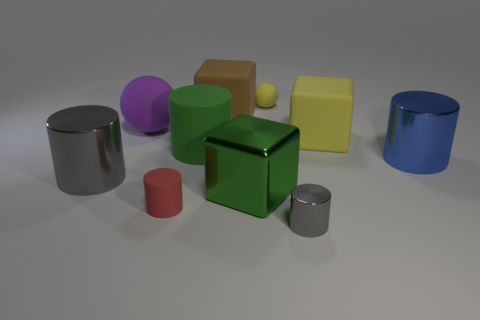What material is the big block that is the same color as the big matte cylinder?
Provide a succinct answer. Metal. What number of things are either large metal cylinders or tiny objects in front of the large blue object?
Provide a succinct answer. 4. Are there fewer green cylinders in front of the large green cube than large gray metal cylinders behind the large yellow rubber thing?
Offer a very short reply. No. What number of other objects are there of the same material as the green cylinder?
Provide a succinct answer. 5. Does the rubber cylinder that is in front of the green rubber object have the same color as the tiny shiny thing?
Offer a terse response. No. Are there any yellow objects that are to the left of the big matte cylinder that is in front of the big yellow block?
Your answer should be very brief. No. There is a large object that is both to the left of the brown block and right of the small red object; what is its material?
Provide a short and direct response. Rubber. What is the shape of the green thing that is made of the same material as the tiny gray thing?
Offer a terse response. Cube. Are there any other things that have the same shape as the purple matte thing?
Your answer should be compact. Yes. Is the material of the gray cylinder on the left side of the red rubber cylinder the same as the big yellow object?
Give a very brief answer. No. 